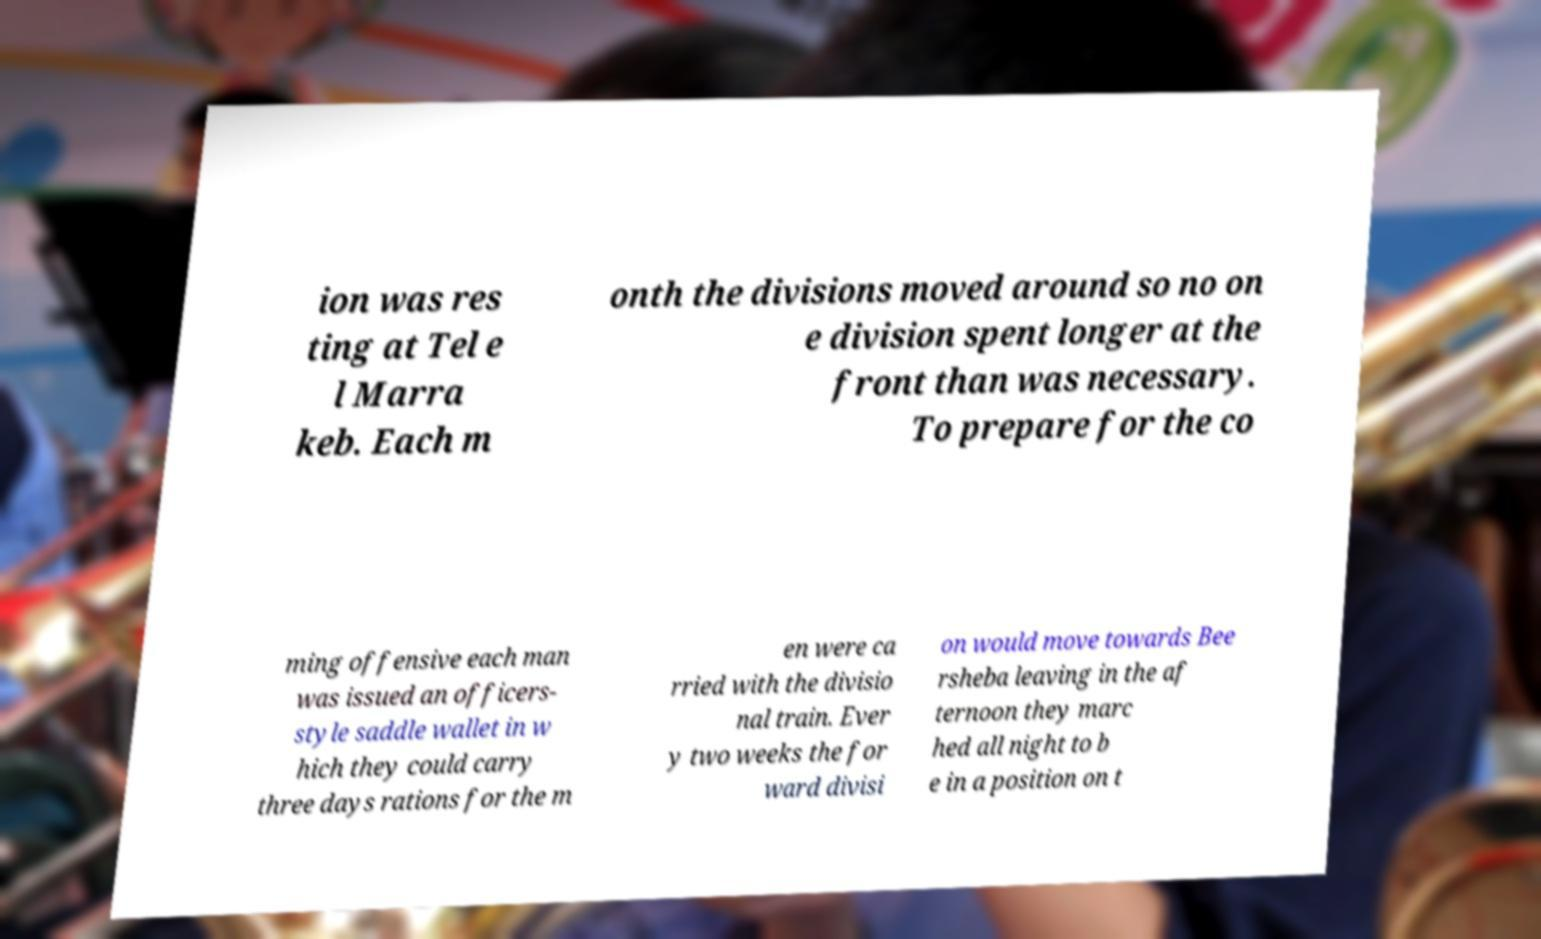For documentation purposes, I need the text within this image transcribed. Could you provide that? ion was res ting at Tel e l Marra keb. Each m onth the divisions moved around so no on e division spent longer at the front than was necessary. To prepare for the co ming offensive each man was issued an officers- style saddle wallet in w hich they could carry three days rations for the m en were ca rried with the divisio nal train. Ever y two weeks the for ward divisi on would move towards Bee rsheba leaving in the af ternoon they marc hed all night to b e in a position on t 